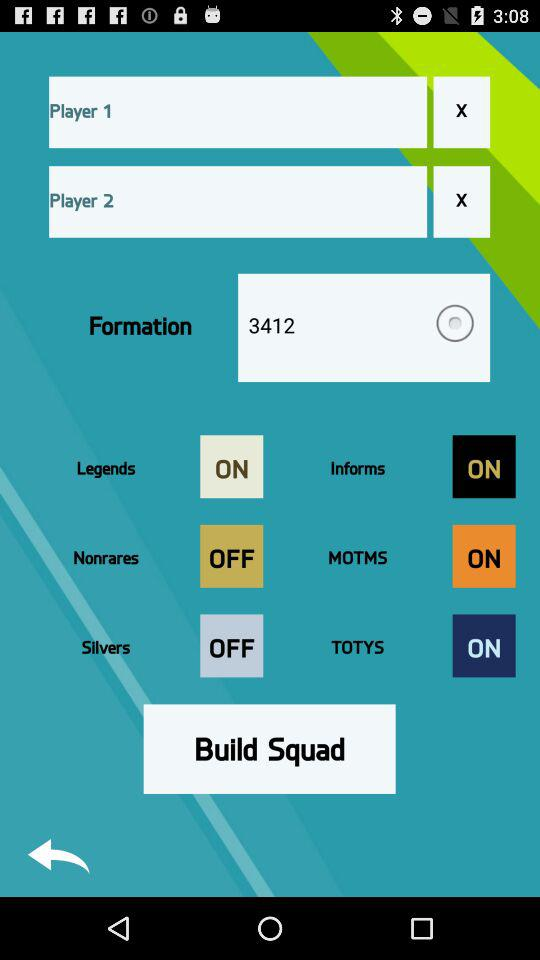What is the status of "Legends"? The status is "on". 